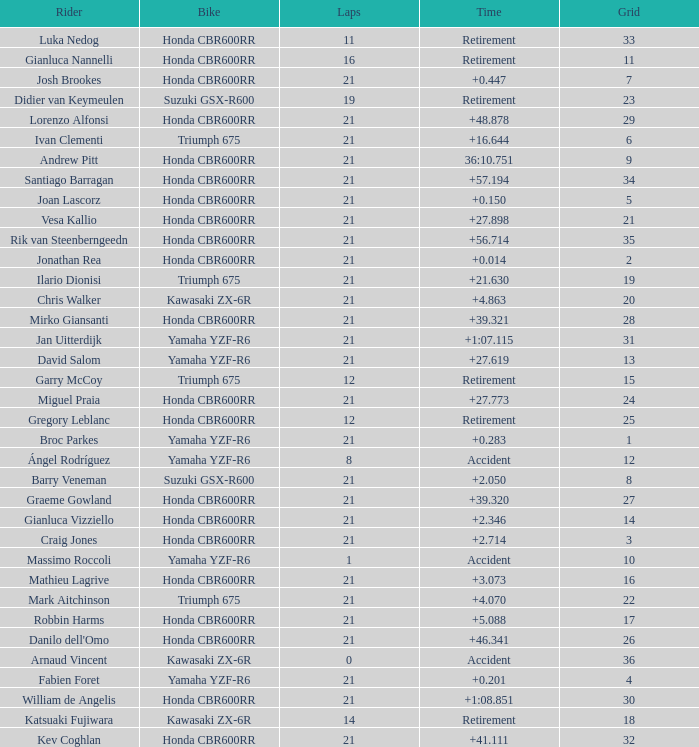What driver had the highest grid position with a time of +0.283? 1.0. 